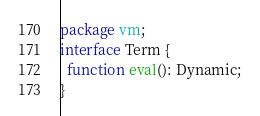<code> <loc_0><loc_0><loc_500><loc_500><_Haxe_>package vm;
interface Term {
  function eval(): Dynamic;
}
</code> 